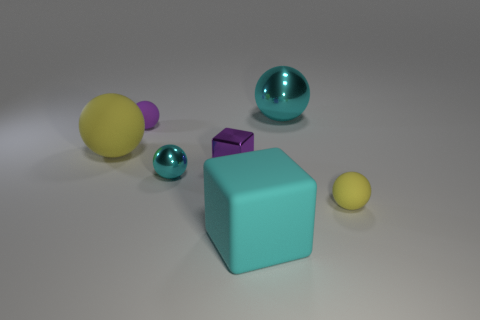How many objects are either large cyan matte objects or blue spheres?
Provide a short and direct response. 1. Is there any other thing that is the same shape as the small yellow matte thing?
Give a very brief answer. Yes. What is the shape of the matte object that is on the right side of the large rubber object that is in front of the small yellow rubber thing?
Ensure brevity in your answer.  Sphere. There is a small thing that is made of the same material as the purple ball; what is its shape?
Offer a very short reply. Sphere. What is the size of the yellow sphere behind the cyan metal ball that is in front of the large metallic sphere?
Ensure brevity in your answer.  Large. What shape is the large cyan shiny thing?
Offer a terse response. Sphere. How many tiny things are cyan rubber things or matte things?
Give a very brief answer. 2. There is a purple thing that is the same shape as the big yellow rubber object; what is its size?
Your answer should be very brief. Small. How many yellow rubber things are both to the left of the big cyan matte cube and on the right side of the rubber cube?
Your answer should be compact. 0. There is a big yellow matte thing; is it the same shape as the big rubber object that is in front of the small cyan thing?
Provide a short and direct response. No. 